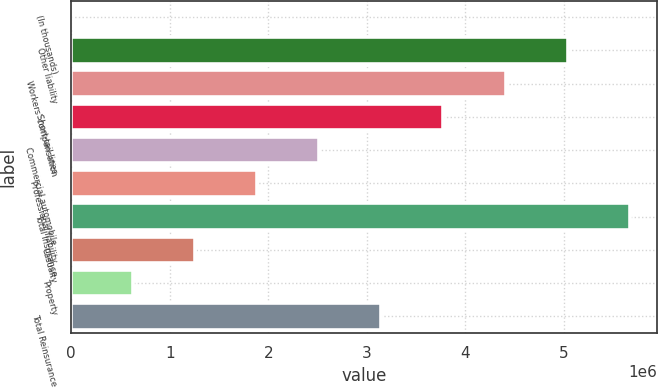Convert chart to OTSL. <chart><loc_0><loc_0><loc_500><loc_500><bar_chart><fcel>(In thousands)<fcel>Other liability<fcel>Workers' compensation<fcel>Short-tail lines<fcel>Commercial automobile<fcel>Professional liability<fcel>Total Insurance<fcel>Casualty<fcel>Property<fcel>Total Reinsurance<nl><fcel>2016<fcel>5.03508e+06<fcel>4.40595e+06<fcel>3.77682e+06<fcel>2.51855e+06<fcel>1.88942e+06<fcel>5.66421e+06<fcel>1.26028e+06<fcel>631149<fcel>3.14768e+06<nl></chart> 